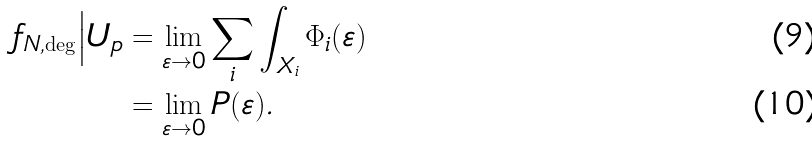Convert formula to latex. <formula><loc_0><loc_0><loc_500><loc_500>f _ { N , \deg } \Big | U _ { p } & = \lim _ { \varepsilon \rightarrow 0 } \sum _ { i } \int _ { X _ { i } } \Phi _ { i } ( \varepsilon ) \\ & = \lim _ { \varepsilon \rightarrow 0 } P ( \varepsilon ) .</formula> 